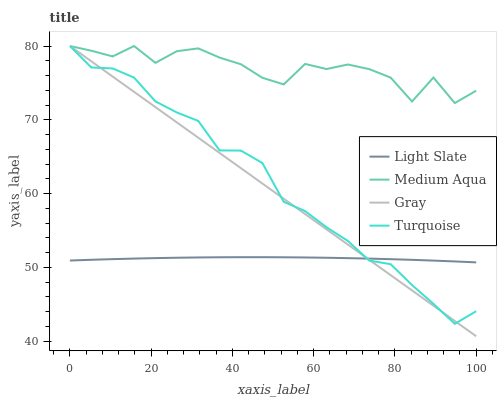Does Light Slate have the minimum area under the curve?
Answer yes or no. Yes. Does Medium Aqua have the maximum area under the curve?
Answer yes or no. Yes. Does Gray have the minimum area under the curve?
Answer yes or no. No. Does Gray have the maximum area under the curve?
Answer yes or no. No. Is Gray the smoothest?
Answer yes or no. Yes. Is Medium Aqua the roughest?
Answer yes or no. Yes. Is Turquoise the smoothest?
Answer yes or no. No. Is Turquoise the roughest?
Answer yes or no. No. Does Gray have the lowest value?
Answer yes or no. Yes. Does Turquoise have the lowest value?
Answer yes or no. No. Does Medium Aqua have the highest value?
Answer yes or no. Yes. Is Light Slate less than Medium Aqua?
Answer yes or no. Yes. Is Medium Aqua greater than Light Slate?
Answer yes or no. Yes. Does Turquoise intersect Medium Aqua?
Answer yes or no. Yes. Is Turquoise less than Medium Aqua?
Answer yes or no. No. Is Turquoise greater than Medium Aqua?
Answer yes or no. No. Does Light Slate intersect Medium Aqua?
Answer yes or no. No. 